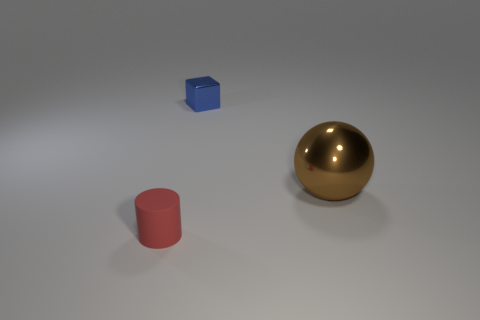Are there any other things that have the same size as the brown object?
Your answer should be very brief. No. What is the tiny cylinder made of?
Your answer should be compact. Rubber. What size is the object that is both to the left of the big metallic object and in front of the blue metal thing?
Provide a short and direct response. Small. Is the number of tiny red cylinders that are right of the tiny blue cube less than the number of blue blocks?
Keep it short and to the point. Yes. What shape is the other rubber thing that is the same size as the blue thing?
Your answer should be compact. Cylinder. How many other things are the same color as the tiny rubber thing?
Make the answer very short. 0. Do the sphere and the shiny block have the same size?
Provide a short and direct response. No. What number of things are large green metal balls or tiny objects behind the rubber object?
Provide a short and direct response. 1. Are there fewer small blue blocks on the right side of the rubber cylinder than objects that are left of the big brown ball?
Provide a short and direct response. Yes. What number of other objects are the same material as the cylinder?
Your answer should be very brief. 0. 